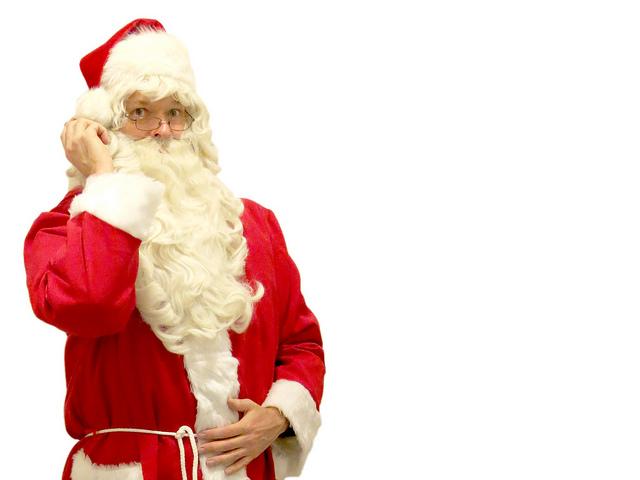What holiday does this man represent?
Write a very short answer. Christmas. Does this man keep animals at home?
Be succinct. Yes. Is this man wearing glasses?
Give a very brief answer. Yes. 